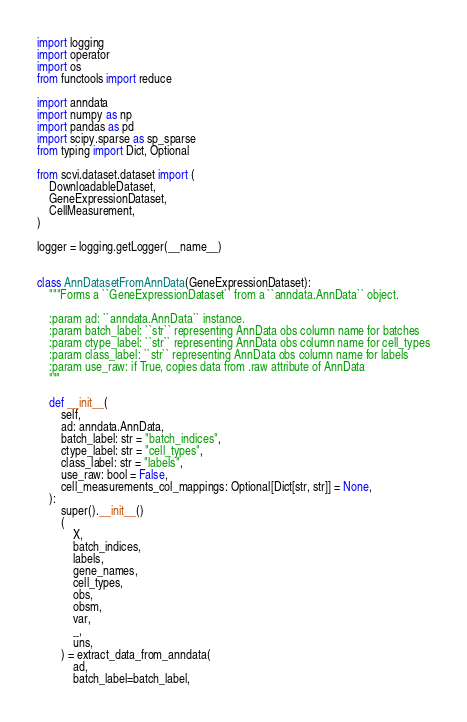<code> <loc_0><loc_0><loc_500><loc_500><_Python_>import logging
import operator
import os
from functools import reduce

import anndata
import numpy as np
import pandas as pd
import scipy.sparse as sp_sparse
from typing import Dict, Optional

from scvi.dataset.dataset import (
    DownloadableDataset,
    GeneExpressionDataset,
    CellMeasurement,
)

logger = logging.getLogger(__name__)


class AnnDatasetFromAnnData(GeneExpressionDataset):
    """Forms a ``GeneExpressionDataset`` from a ``anndata.AnnData`` object.

    :param ad: ``anndata.AnnData`` instance.
    :param batch_label: ``str`` representing AnnData obs column name for batches
    :param ctype_label: ``str`` representing AnnData obs column name for cell_types
    :param class_label: ``str`` representing AnnData obs column name for labels
    :param use_raw: if True, copies data from .raw attribute of AnnData
    """

    def __init__(
        self,
        ad: anndata.AnnData,
        batch_label: str = "batch_indices",
        ctype_label: str = "cell_types",
        class_label: str = "labels",
        use_raw: bool = False,
        cell_measurements_col_mappings: Optional[Dict[str, str]] = None,
    ):
        super().__init__()
        (
            X,
            batch_indices,
            labels,
            gene_names,
            cell_types,
            obs,
            obsm,
            var,
            _,
            uns,
        ) = extract_data_from_anndata(
            ad,
            batch_label=batch_label,</code> 